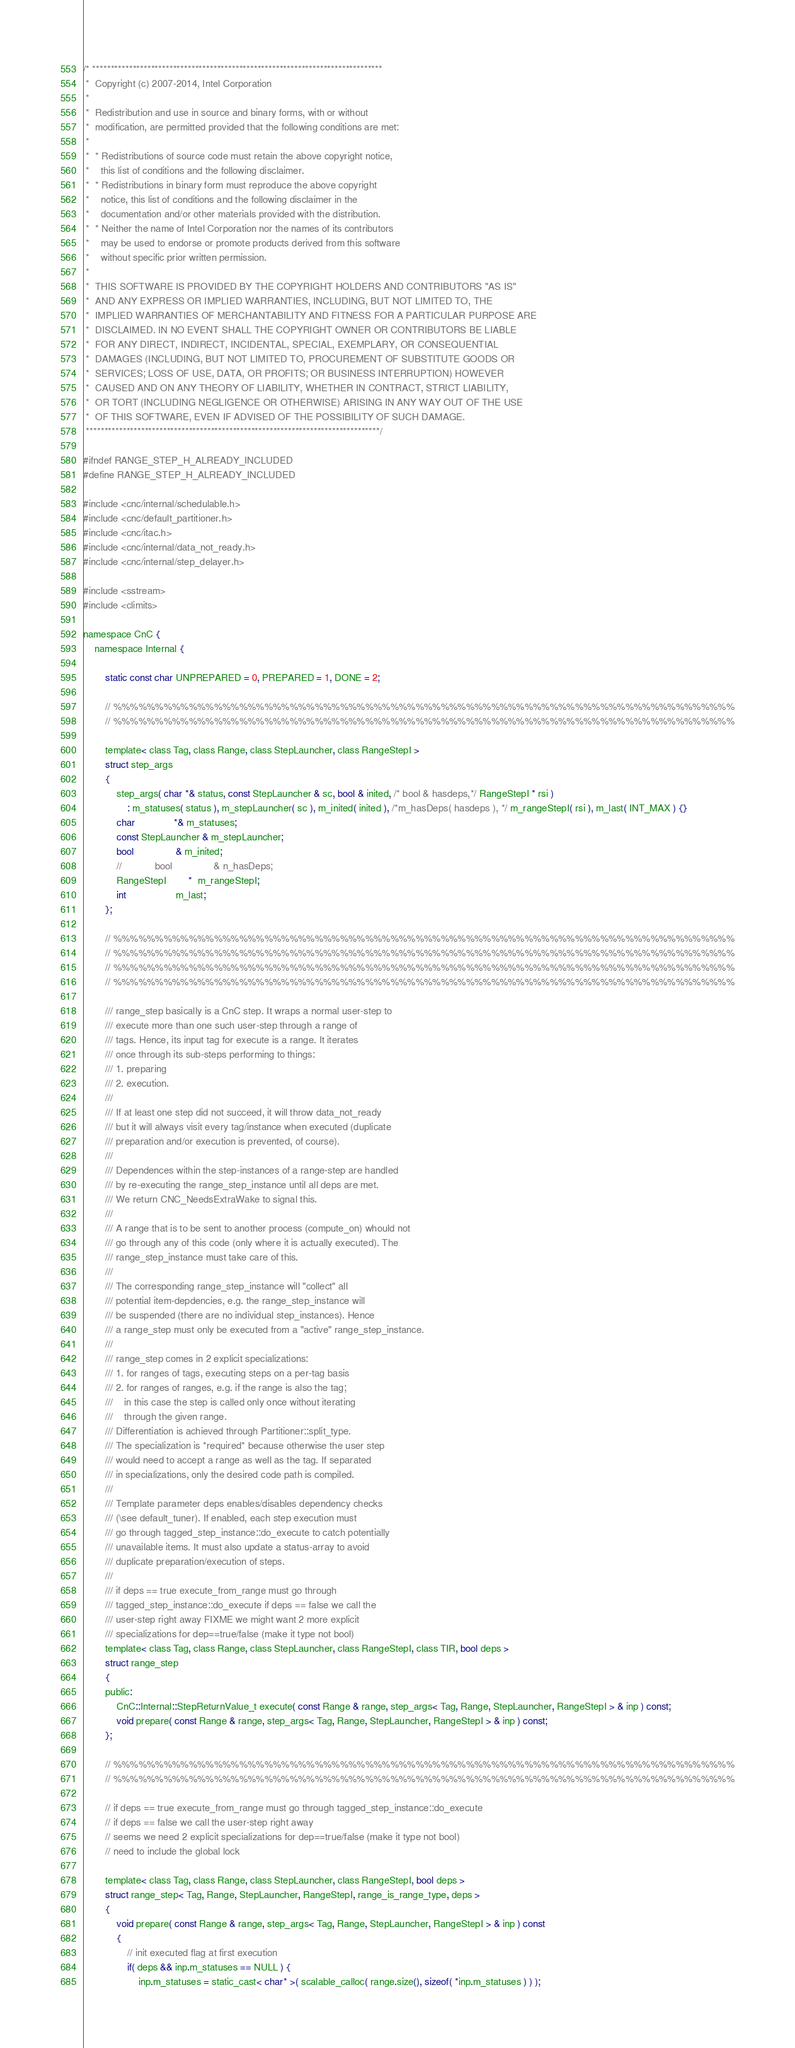Convert code to text. <code><loc_0><loc_0><loc_500><loc_500><_C_>/* *******************************************************************************
 *  Copyright (c) 2007-2014, Intel Corporation
 *
 *  Redistribution and use in source and binary forms, with or without
 *  modification, are permitted provided that the following conditions are met:
 *
 *  * Redistributions of source code must retain the above copyright notice,
 *    this list of conditions and the following disclaimer.
 *  * Redistributions in binary form must reproduce the above copyright
 *    notice, this list of conditions and the following disclaimer in the
 *    documentation and/or other materials provided with the distribution.
 *  * Neither the name of Intel Corporation nor the names of its contributors
 *    may be used to endorse or promote products derived from this software
 *    without specific prior written permission.
 *
 *  THIS SOFTWARE IS PROVIDED BY THE COPYRIGHT HOLDERS AND CONTRIBUTORS "AS IS"
 *  AND ANY EXPRESS OR IMPLIED WARRANTIES, INCLUDING, BUT NOT LIMITED TO, THE
 *  IMPLIED WARRANTIES OF MERCHANTABILITY AND FITNESS FOR A PARTICULAR PURPOSE ARE
 *  DISCLAIMED. IN NO EVENT SHALL THE COPYRIGHT OWNER OR CONTRIBUTORS BE LIABLE
 *  FOR ANY DIRECT, INDIRECT, INCIDENTAL, SPECIAL, EXEMPLARY, OR CONSEQUENTIAL
 *  DAMAGES (INCLUDING, BUT NOT LIMITED TO, PROCUREMENT OF SUBSTITUTE GOODS OR
 *  SERVICES; LOSS OF USE, DATA, OR PROFITS; OR BUSINESS INTERRUPTION) HOWEVER
 *  CAUSED AND ON ANY THEORY OF LIABILITY, WHETHER IN CONTRACT, STRICT LIABILITY,
 *  OR TORT (INCLUDING NEGLIGENCE OR OTHERWISE) ARISING IN ANY WAY OUT OF THE USE
 *  OF THIS SOFTWARE, EVEN IF ADVISED OF THE POSSIBILITY OF SUCH DAMAGE.
 ********************************************************************************/

#ifndef RANGE_STEP_H_ALREADY_INCLUDED
#define RANGE_STEP_H_ALREADY_INCLUDED

#include <cnc/internal/schedulable.h>
#include <cnc/default_partitioner.h>
#include <cnc/itac.h>
#include <cnc/internal/data_not_ready.h>
#include <cnc/internal/step_delayer.h>

#include <sstream>
#include <climits>

namespace CnC {
    namespace Internal {

        static const char UNPREPARED = 0, PREPARED = 1, DONE = 2;

        // %%%%%%%%%%%%%%%%%%%%%%%%%%%%%%%%%%%%%%%%%%%%%%%%%%%%%%%%%%%%%%%%%%%%%%%%%%
        // %%%%%%%%%%%%%%%%%%%%%%%%%%%%%%%%%%%%%%%%%%%%%%%%%%%%%%%%%%%%%%%%%%%%%%%%%%

        template< class Tag, class Range, class StepLauncher, class RangeStepI >
        struct step_args
        {
            step_args( char *& status, const StepLauncher & sc, bool & inited, /* bool & hasdeps,*/ RangeStepI * rsi )
                : m_statuses( status ), m_stepLauncher( sc ), m_inited( inited ), /*m_hasDeps( hasdeps ), */ m_rangeStepI( rsi ), m_last( INT_MAX ) {}
            char              *& m_statuses;
            const StepLauncher & m_stepLauncher;
            bool               & m_inited;
            //            bool               & n_hasDeps;
            RangeStepI        *  m_rangeStepI;
            int                  m_last;
        };

        // %%%%%%%%%%%%%%%%%%%%%%%%%%%%%%%%%%%%%%%%%%%%%%%%%%%%%%%%%%%%%%%%%%%%%%%%%%
        // %%%%%%%%%%%%%%%%%%%%%%%%%%%%%%%%%%%%%%%%%%%%%%%%%%%%%%%%%%%%%%%%%%%%%%%%%%
        // %%%%%%%%%%%%%%%%%%%%%%%%%%%%%%%%%%%%%%%%%%%%%%%%%%%%%%%%%%%%%%%%%%%%%%%%%%
        // %%%%%%%%%%%%%%%%%%%%%%%%%%%%%%%%%%%%%%%%%%%%%%%%%%%%%%%%%%%%%%%%%%%%%%%%%%

        /// range_step basically is a CnC step. It wraps a normal user-step to
        /// execute more than one such user-step through a range of
        /// tags. Hence, its input tag for execute is a range. It iterates
        /// once through its sub-steps performing to things:
        /// 1. preparing
        /// 2. execution.
        ///
        /// If at least one step did not succeed, it will throw data_not_ready
        /// but it will always visit every tag/instance when executed (duplicate 
        /// preparation and/or execution is prevented, of course).
        ///
        /// Dependences within the step-instances of a range-step are handled
        /// by re-executing the range_step_instance until all deps are met.
        /// We return CNC_NeedsExtraWake to signal this.
        ///
        /// A range that is to be sent to another process (compute_on) whould not
        /// go through any of this code (only where it is actually executed). The
        /// range_step_instance must take care of this.
        ///
        /// The corresponding range_step_instance will "collect" all 
        /// potential item-depdencies, e.g. the range_step_instance will
        /// be suspended (there are no individual step_instances). Hence
        /// a range_step must only be executed from a "active" range_step_instance.
        ///
        /// range_step comes in 2 explicit specializations:
        /// 1. for ranges of tags, executing steps on a per-tag basis
        /// 2. for ranges of ranges, e.g. if the range is also the tag;
        ///    in this case the step is called only once without iterating
        ///    through the given range.
        /// Differentiation is achieved through Partitioner::split_type.
        /// The specialization is *required* because otherwise the user step
        /// would need to accept a range as well as the tag. If separated
        /// in specializations, only the desired code path is compiled.
        ///
        /// Template parameter deps enables/disables dependency checks
        /// (\see default_tuner). If enabled, each step execution must
        /// go through tagged_step_instance::do_execute to catch potentially
        /// unavailable items. It must also update a status-array to avoid
        /// duplicate preparation/execution of steps.
        ///
        /// if deps == true execute_from_range must go through
        /// tagged_step_instance::do_execute if deps == false we call the
        /// user-step right away FIXME we might want 2 more explicit
        /// specializations for dep==true/false (make it type not bool)
        template< class Tag, class Range, class StepLauncher, class RangeStepI, class TIR, bool deps >
        struct range_step
        {
        public:
            CnC::Internal::StepReturnValue_t execute( const Range & range, step_args< Tag, Range, StepLauncher, RangeStepI > & inp ) const;
            void prepare( const Range & range, step_args< Tag, Range, StepLauncher, RangeStepI > & inp ) const;
        };

        // %%%%%%%%%%%%%%%%%%%%%%%%%%%%%%%%%%%%%%%%%%%%%%%%%%%%%%%%%%%%%%%%%%%%%%%%%%
        // %%%%%%%%%%%%%%%%%%%%%%%%%%%%%%%%%%%%%%%%%%%%%%%%%%%%%%%%%%%%%%%%%%%%%%%%%%

        // if deps == true execute_from_range must go through tagged_step_instance::do_execute
        // if deps == false we call the user-step right away
        // seems we need 2 explicit specializations for dep==true/false (make it type not bool)
        // need to include the global lock

        template< class Tag, class Range, class StepLauncher, class RangeStepI, bool deps >
        struct range_step< Tag, Range, StepLauncher, RangeStepI, range_is_range_type, deps >
        {
            void prepare( const Range & range, step_args< Tag, Range, StepLauncher, RangeStepI > & inp ) const
            {
                // init executed flag at first execution
                if( deps && inp.m_statuses == NULL ) {
                    inp.m_statuses = static_cast< char* >( scalable_calloc( range.size(), sizeof( *inp.m_statuses ) ) );</code> 